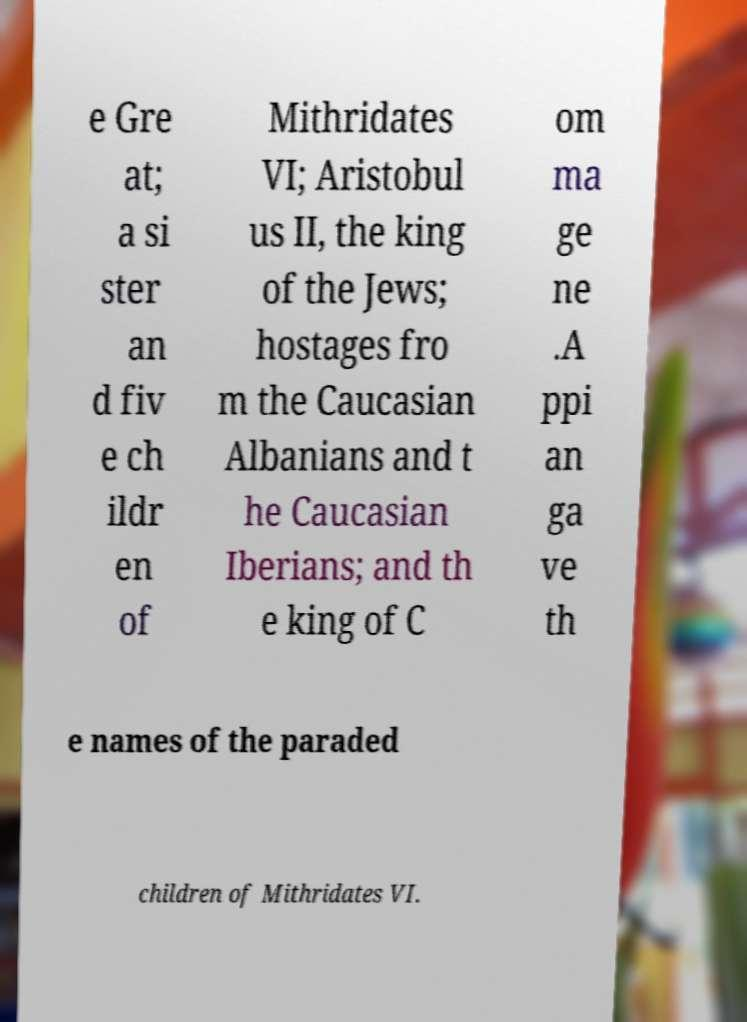What messages or text are displayed in this image? I need them in a readable, typed format. e Gre at; a si ster an d fiv e ch ildr en of Mithridates VI; Aristobul us II, the king of the Jews; hostages fro m the Caucasian Albanians and t he Caucasian Iberians; and th e king of C om ma ge ne .A ppi an ga ve th e names of the paraded children of Mithridates VI. 